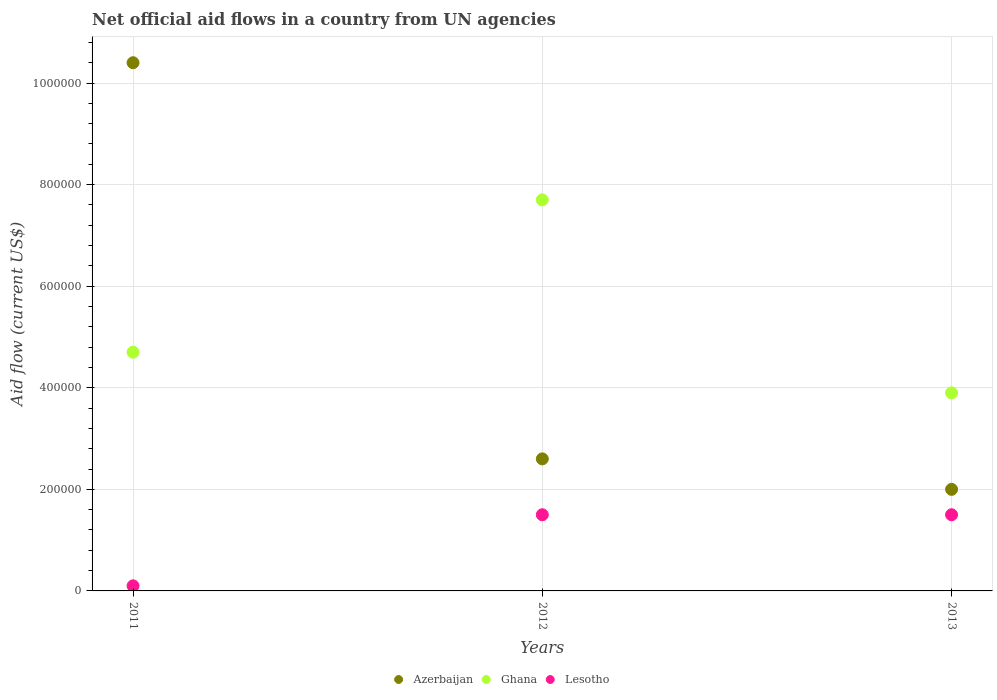Is the number of dotlines equal to the number of legend labels?
Offer a terse response. Yes. What is the net official aid flow in Azerbaijan in 2012?
Give a very brief answer. 2.60e+05. Across all years, what is the maximum net official aid flow in Azerbaijan?
Keep it short and to the point. 1.04e+06. Across all years, what is the minimum net official aid flow in Azerbaijan?
Provide a short and direct response. 2.00e+05. In which year was the net official aid flow in Azerbaijan maximum?
Provide a succinct answer. 2011. In which year was the net official aid flow in Azerbaijan minimum?
Keep it short and to the point. 2013. What is the total net official aid flow in Azerbaijan in the graph?
Provide a succinct answer. 1.50e+06. What is the difference between the net official aid flow in Ghana in 2011 and the net official aid flow in Azerbaijan in 2012?
Offer a terse response. 2.10e+05. What is the average net official aid flow in Lesotho per year?
Your answer should be compact. 1.03e+05. In the year 2012, what is the difference between the net official aid flow in Ghana and net official aid flow in Azerbaijan?
Ensure brevity in your answer.  5.10e+05. What is the ratio of the net official aid flow in Ghana in 2012 to that in 2013?
Your answer should be compact. 1.97. Is the net official aid flow in Azerbaijan in 2011 less than that in 2013?
Provide a short and direct response. No. What is the difference between the highest and the lowest net official aid flow in Ghana?
Keep it short and to the point. 3.80e+05. In how many years, is the net official aid flow in Lesotho greater than the average net official aid flow in Lesotho taken over all years?
Keep it short and to the point. 2. Is the sum of the net official aid flow in Ghana in 2012 and 2013 greater than the maximum net official aid flow in Azerbaijan across all years?
Provide a short and direct response. Yes. Is it the case that in every year, the sum of the net official aid flow in Ghana and net official aid flow in Lesotho  is greater than the net official aid flow in Azerbaijan?
Make the answer very short. No. Does the net official aid flow in Lesotho monotonically increase over the years?
Offer a terse response. No. Is the net official aid flow in Azerbaijan strictly less than the net official aid flow in Ghana over the years?
Ensure brevity in your answer.  No. How many years are there in the graph?
Offer a terse response. 3. What is the difference between two consecutive major ticks on the Y-axis?
Give a very brief answer. 2.00e+05. Are the values on the major ticks of Y-axis written in scientific E-notation?
Ensure brevity in your answer.  No. Where does the legend appear in the graph?
Offer a very short reply. Bottom center. How are the legend labels stacked?
Your answer should be compact. Horizontal. What is the title of the graph?
Make the answer very short. Net official aid flows in a country from UN agencies. Does "Uruguay" appear as one of the legend labels in the graph?
Make the answer very short. No. What is the label or title of the X-axis?
Give a very brief answer. Years. What is the Aid flow (current US$) of Azerbaijan in 2011?
Provide a succinct answer. 1.04e+06. What is the Aid flow (current US$) of Lesotho in 2011?
Keep it short and to the point. 10000. What is the Aid flow (current US$) in Ghana in 2012?
Offer a very short reply. 7.70e+05. What is the Aid flow (current US$) of Lesotho in 2012?
Provide a short and direct response. 1.50e+05. What is the Aid flow (current US$) of Azerbaijan in 2013?
Ensure brevity in your answer.  2.00e+05. What is the Aid flow (current US$) of Ghana in 2013?
Your response must be concise. 3.90e+05. Across all years, what is the maximum Aid flow (current US$) of Azerbaijan?
Your answer should be compact. 1.04e+06. Across all years, what is the maximum Aid flow (current US$) in Ghana?
Ensure brevity in your answer.  7.70e+05. Across all years, what is the maximum Aid flow (current US$) of Lesotho?
Your answer should be compact. 1.50e+05. Across all years, what is the minimum Aid flow (current US$) in Ghana?
Ensure brevity in your answer.  3.90e+05. What is the total Aid flow (current US$) of Azerbaijan in the graph?
Keep it short and to the point. 1.50e+06. What is the total Aid flow (current US$) in Ghana in the graph?
Your response must be concise. 1.63e+06. What is the difference between the Aid flow (current US$) in Azerbaijan in 2011 and that in 2012?
Your answer should be compact. 7.80e+05. What is the difference between the Aid flow (current US$) of Ghana in 2011 and that in 2012?
Your response must be concise. -3.00e+05. What is the difference between the Aid flow (current US$) in Lesotho in 2011 and that in 2012?
Offer a terse response. -1.40e+05. What is the difference between the Aid flow (current US$) of Azerbaijan in 2011 and that in 2013?
Make the answer very short. 8.40e+05. What is the difference between the Aid flow (current US$) of Azerbaijan in 2012 and that in 2013?
Your answer should be very brief. 6.00e+04. What is the difference between the Aid flow (current US$) in Ghana in 2012 and that in 2013?
Make the answer very short. 3.80e+05. What is the difference between the Aid flow (current US$) in Lesotho in 2012 and that in 2013?
Provide a short and direct response. 0. What is the difference between the Aid flow (current US$) in Azerbaijan in 2011 and the Aid flow (current US$) in Ghana in 2012?
Make the answer very short. 2.70e+05. What is the difference between the Aid flow (current US$) of Azerbaijan in 2011 and the Aid flow (current US$) of Lesotho in 2012?
Provide a succinct answer. 8.90e+05. What is the difference between the Aid flow (current US$) in Azerbaijan in 2011 and the Aid flow (current US$) in Ghana in 2013?
Make the answer very short. 6.50e+05. What is the difference between the Aid flow (current US$) of Azerbaijan in 2011 and the Aid flow (current US$) of Lesotho in 2013?
Provide a succinct answer. 8.90e+05. What is the difference between the Aid flow (current US$) of Ghana in 2011 and the Aid flow (current US$) of Lesotho in 2013?
Ensure brevity in your answer.  3.20e+05. What is the difference between the Aid flow (current US$) in Azerbaijan in 2012 and the Aid flow (current US$) in Ghana in 2013?
Your answer should be very brief. -1.30e+05. What is the difference between the Aid flow (current US$) of Ghana in 2012 and the Aid flow (current US$) of Lesotho in 2013?
Offer a very short reply. 6.20e+05. What is the average Aid flow (current US$) in Ghana per year?
Make the answer very short. 5.43e+05. What is the average Aid flow (current US$) in Lesotho per year?
Your answer should be very brief. 1.03e+05. In the year 2011, what is the difference between the Aid flow (current US$) of Azerbaijan and Aid flow (current US$) of Ghana?
Keep it short and to the point. 5.70e+05. In the year 2011, what is the difference between the Aid flow (current US$) of Azerbaijan and Aid flow (current US$) of Lesotho?
Offer a terse response. 1.03e+06. In the year 2011, what is the difference between the Aid flow (current US$) of Ghana and Aid flow (current US$) of Lesotho?
Make the answer very short. 4.60e+05. In the year 2012, what is the difference between the Aid flow (current US$) in Azerbaijan and Aid flow (current US$) in Ghana?
Give a very brief answer. -5.10e+05. In the year 2012, what is the difference between the Aid flow (current US$) of Azerbaijan and Aid flow (current US$) of Lesotho?
Provide a succinct answer. 1.10e+05. In the year 2012, what is the difference between the Aid flow (current US$) of Ghana and Aid flow (current US$) of Lesotho?
Provide a succinct answer. 6.20e+05. In the year 2013, what is the difference between the Aid flow (current US$) in Azerbaijan and Aid flow (current US$) in Ghana?
Provide a short and direct response. -1.90e+05. In the year 2013, what is the difference between the Aid flow (current US$) of Azerbaijan and Aid flow (current US$) of Lesotho?
Provide a succinct answer. 5.00e+04. What is the ratio of the Aid flow (current US$) in Ghana in 2011 to that in 2012?
Keep it short and to the point. 0.61. What is the ratio of the Aid flow (current US$) in Lesotho in 2011 to that in 2012?
Your answer should be compact. 0.07. What is the ratio of the Aid flow (current US$) of Ghana in 2011 to that in 2013?
Offer a very short reply. 1.21. What is the ratio of the Aid flow (current US$) in Lesotho in 2011 to that in 2013?
Your response must be concise. 0.07. What is the ratio of the Aid flow (current US$) of Azerbaijan in 2012 to that in 2013?
Your answer should be compact. 1.3. What is the ratio of the Aid flow (current US$) in Ghana in 2012 to that in 2013?
Give a very brief answer. 1.97. What is the difference between the highest and the second highest Aid flow (current US$) in Azerbaijan?
Your answer should be compact. 7.80e+05. What is the difference between the highest and the second highest Aid flow (current US$) of Ghana?
Keep it short and to the point. 3.00e+05. What is the difference between the highest and the lowest Aid flow (current US$) in Azerbaijan?
Make the answer very short. 8.40e+05. 